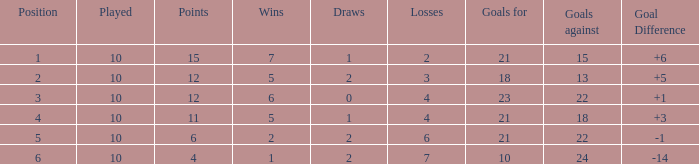Could you parse the entire table? {'header': ['Position', 'Played', 'Points', 'Wins', 'Draws', 'Losses', 'Goals for', 'Goals against', 'Goal Difference'], 'rows': [['1', '10', '15', '7', '1', '2', '21', '15', '+6'], ['2', '10', '12', '5', '2', '3', '18', '13', '+5'], ['3', '10', '12', '6', '0', '4', '23', '22', '+1'], ['4', '10', '11', '5', '1', '4', '21', '18', '+3'], ['5', '10', '6', '2', '2', '6', '21', '22', '-1'], ['6', '10', '4', '1', '2', '7', '10', '24', '-14']]} Can you tell me the sum of Goals against that has the Goals for larger than 10, and the Position of 3, and the Wins smaller than 6? None. 